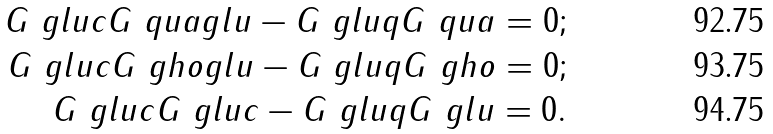Convert formula to latex. <formula><loc_0><loc_0><loc_500><loc_500>G ^ { \ } g l u c G ^ { \ } q u a g l u - G ^ { \ } g l u q G ^ { \ } q u a = 0 ; \\ G ^ { \ } g l u c G ^ { \ } g h o g l u - G ^ { \ } g l u q G ^ { \ } g h o = 0 ; \\ G ^ { \ } g l u c G ^ { \ } g l u c - G ^ { \ } g l u q G ^ { \ } g l u = 0 .</formula> 